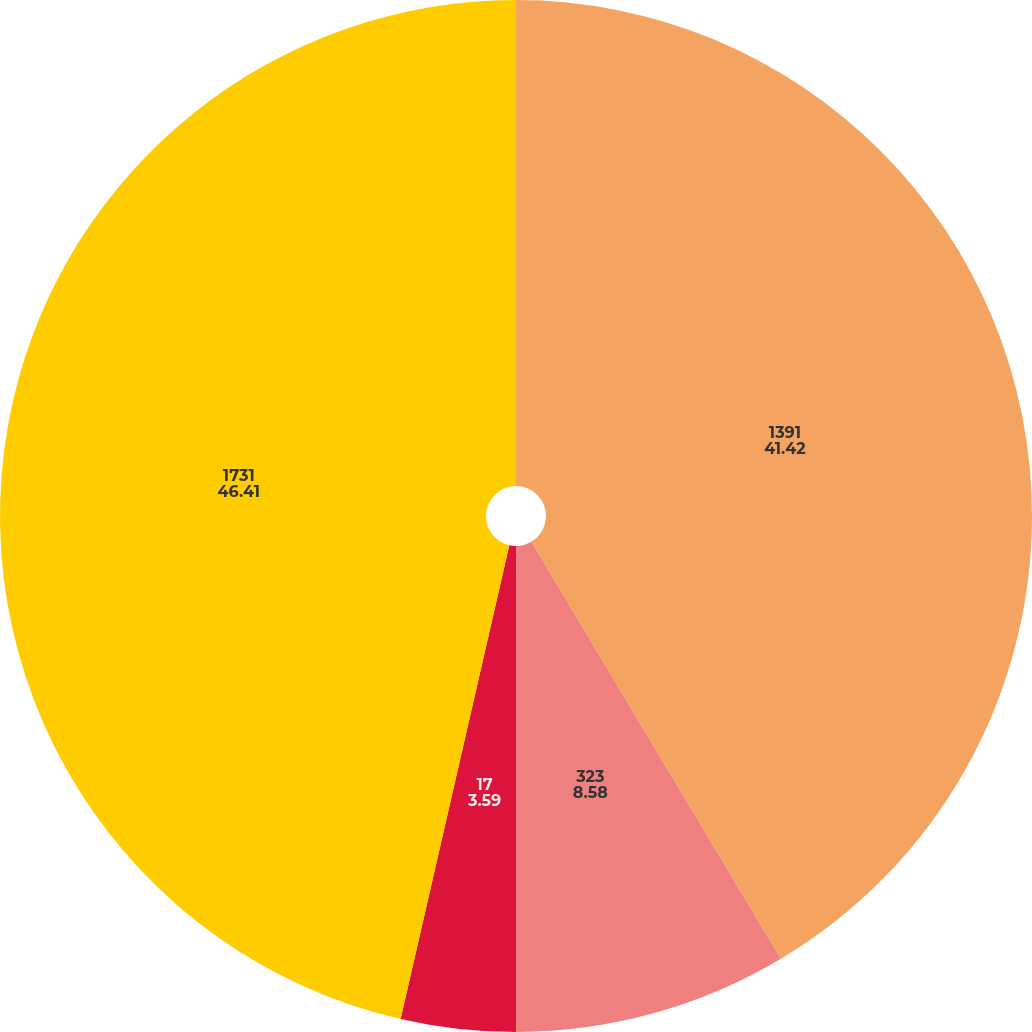Convert chart. <chart><loc_0><loc_0><loc_500><loc_500><pie_chart><fcel>1391<fcel>323<fcel>17<fcel>1731<nl><fcel>41.42%<fcel>8.58%<fcel>3.59%<fcel>46.41%<nl></chart> 